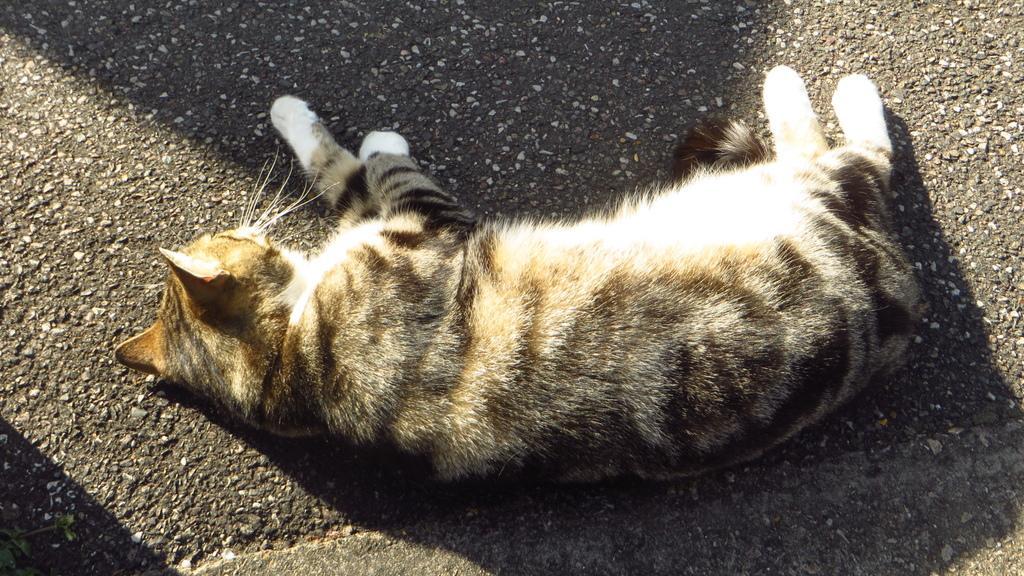Could you give a brief overview of what you see in this image? In this image we can see a cat is lying on road. 